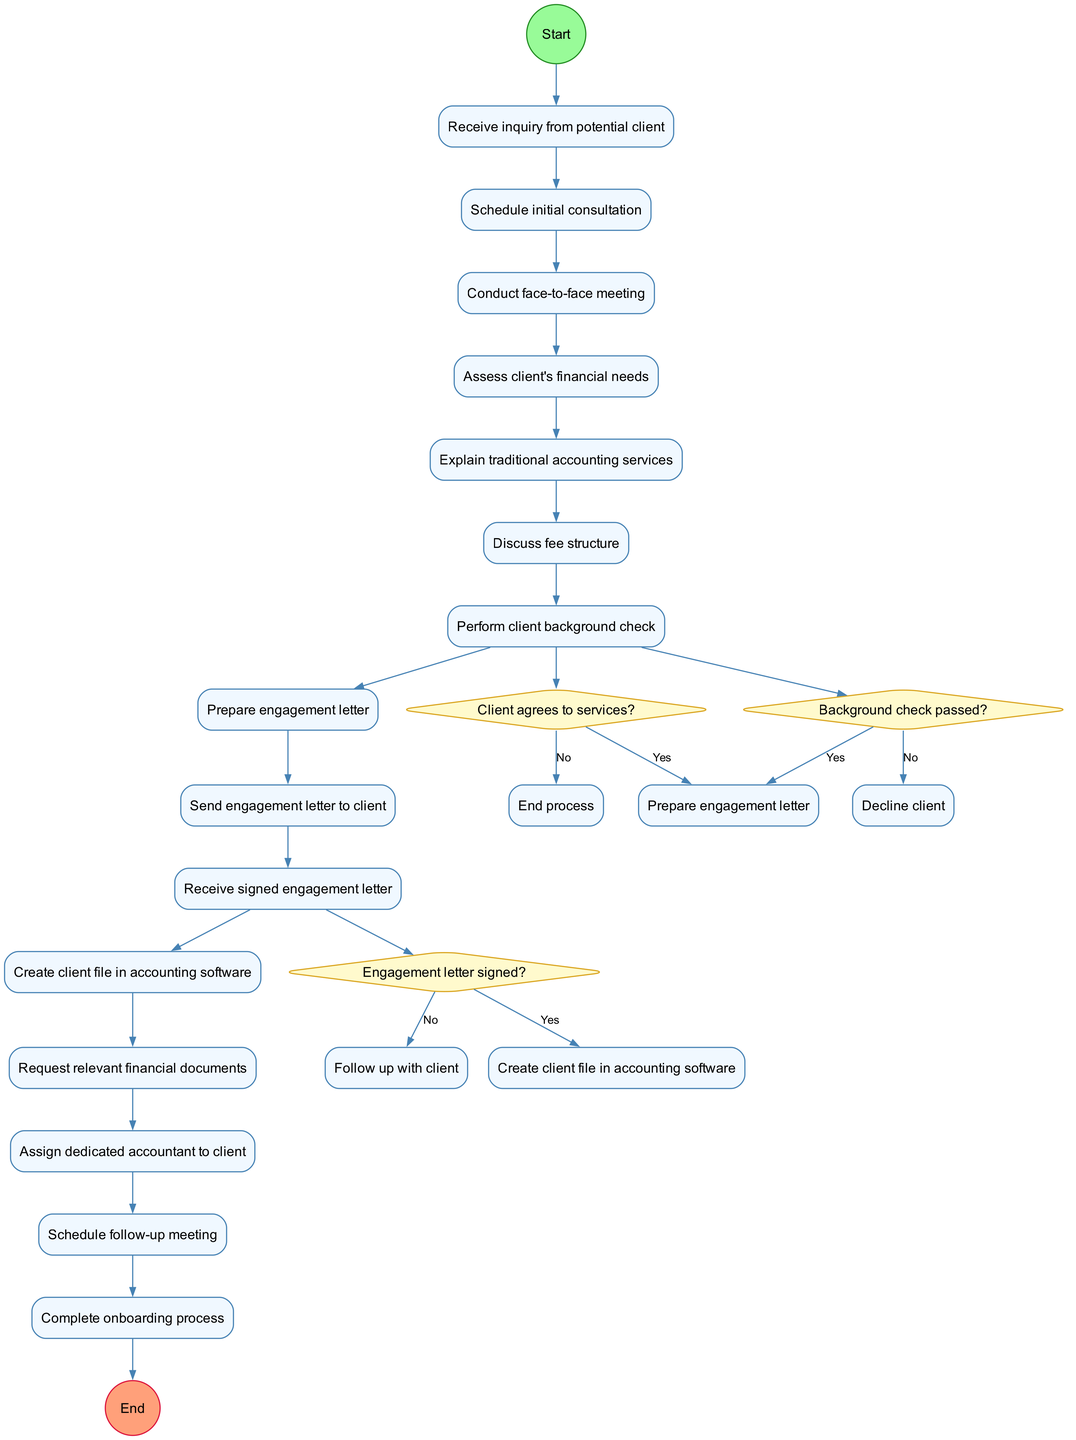What is the first activity in the onboarding process? The first activity is indicated directly after the start node, which is "Receive inquiry from potential client."
Answer: Receive inquiry from potential client How many decision nodes are there in the diagram? The diagram lists three decision nodes. They assess client agreement to services, background check results, and engagement letter status.
Answer: 3 What happens if the client does not agree to the services? According to the diagram, if the client does not agree to the services, the process ends—the flow leads directly to an end node.
Answer: End process What is the last activity before the onboarding process is complete? The last activity is "Schedule follow-up meeting," which is right before the process moves to the end node.
Answer: Schedule follow-up meeting What action follows a successful background check? If the background check passes (the answer is "Yes"), the next action is to "Prepare engagement letter."
Answer: Prepare engagement letter What is the last decision point before completing the onboarding? The last decision node checks whether the engagement letter is signed. It determines if the next step is creating a client file or following up with the client.
Answer: Engagement letter signed? What is the ending node labeled as? The ending node, which signifies the completion of the entire onboarding process, is labeled as "Complete onboarding process."
Answer: Complete onboarding process What is the purpose of the diamond-shaped nodes in the diagram? The diamond-shaped nodes represent decision points in the process where the flow can branch based on the responses to specific questions.
Answer: Decision points 